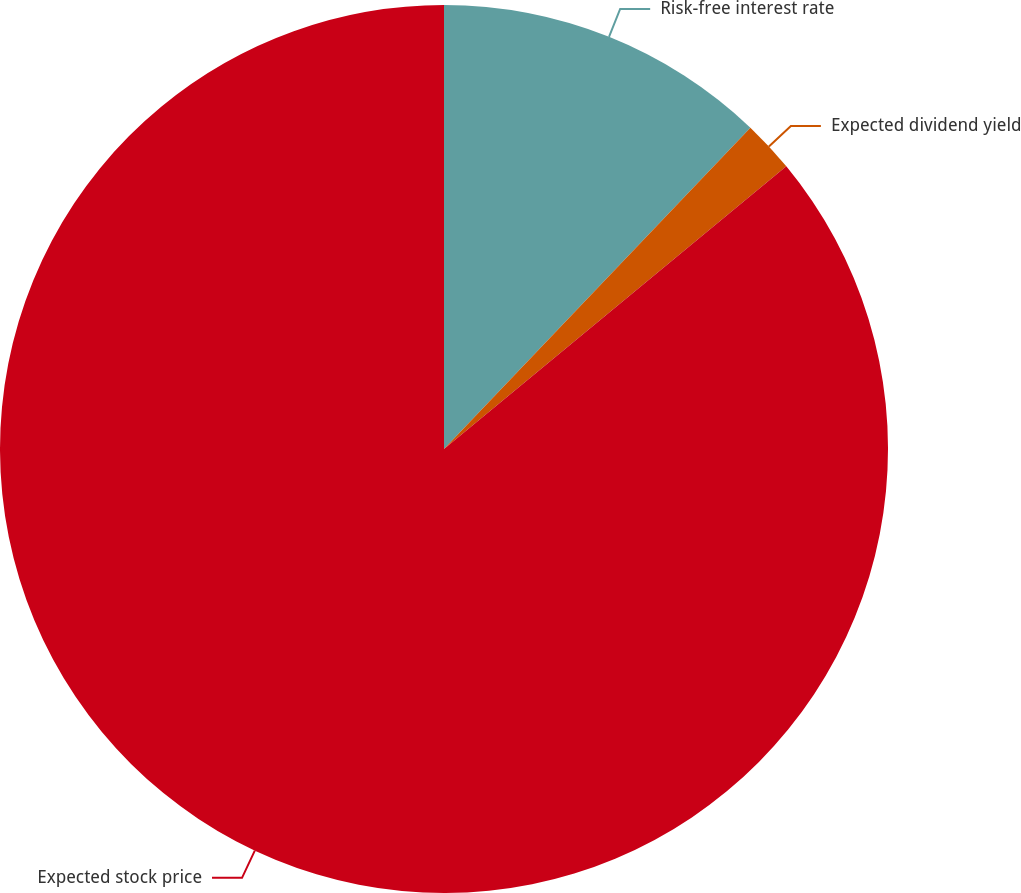Convert chart. <chart><loc_0><loc_0><loc_500><loc_500><pie_chart><fcel>Risk-free interest rate<fcel>Expected dividend yield<fcel>Expected stock price<nl><fcel>12.12%<fcel>1.89%<fcel>85.98%<nl></chart> 